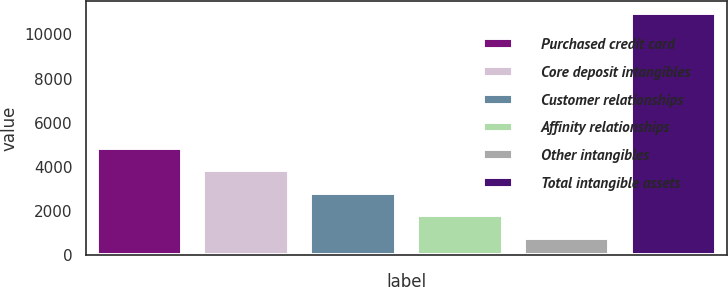<chart> <loc_0><loc_0><loc_500><loc_500><bar_chart><fcel>Purchased credit card<fcel>Core deposit intangibles<fcel>Customer relationships<fcel>Affinity relationships<fcel>Other intangibles<fcel>Total intangible assets<nl><fcel>4843.2<fcel>3824.4<fcel>2805.6<fcel>1786.8<fcel>768<fcel>10956<nl></chart> 